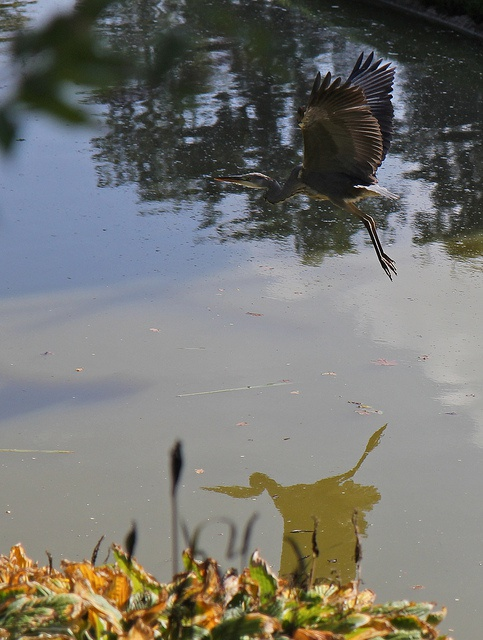Describe the objects in this image and their specific colors. I can see a bird in gray and black tones in this image. 